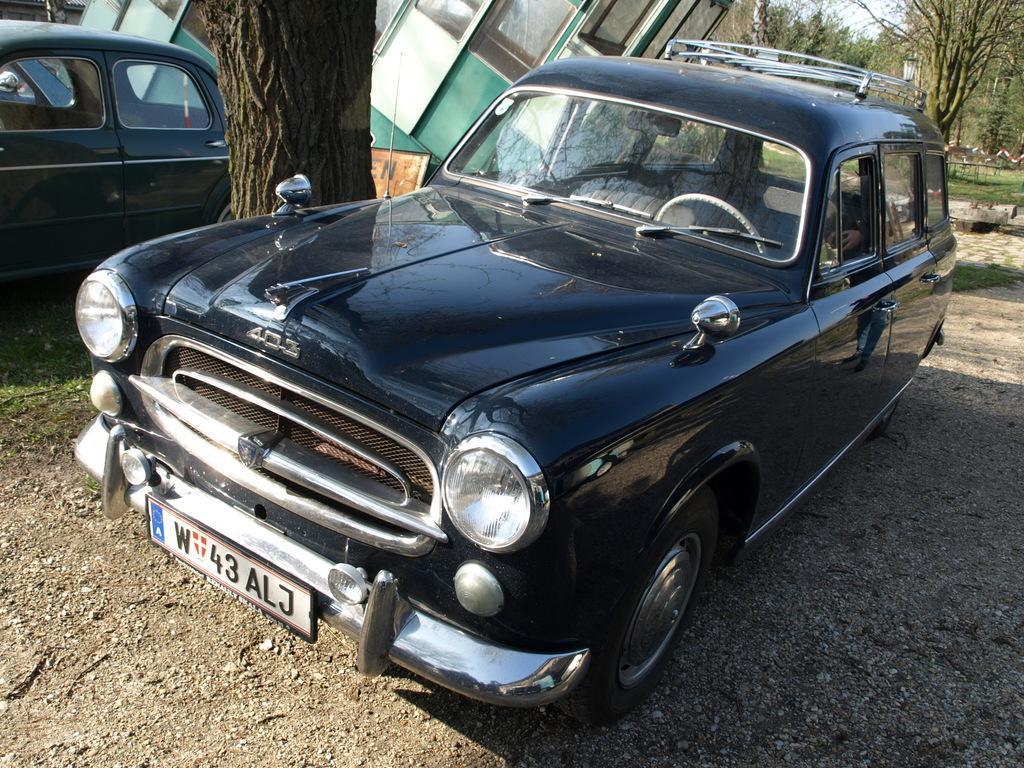Please provide a concise description of this image. In this picture there are vehicles. At the back there are trees and their might be a building. In the foreground there is a reflection of a person on the vehicle. At the top there is sky. At the bottom there is grass and there is ground and at the back there is a street light. 